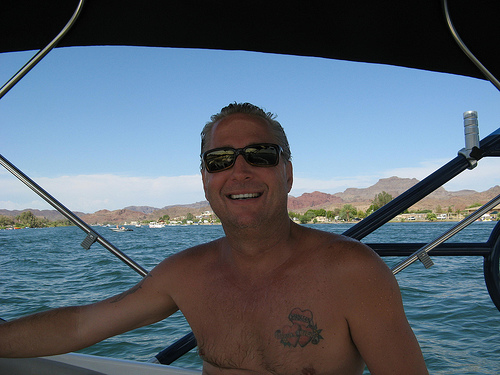<image>
Is the sky behind the water? No. The sky is not behind the water. From this viewpoint, the sky appears to be positioned elsewhere in the scene. 